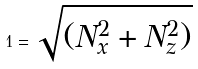<formula> <loc_0><loc_0><loc_500><loc_500>1 = \sqrt { ( N _ { x } ^ { 2 } + N _ { z } ^ { 2 } ) }</formula> 